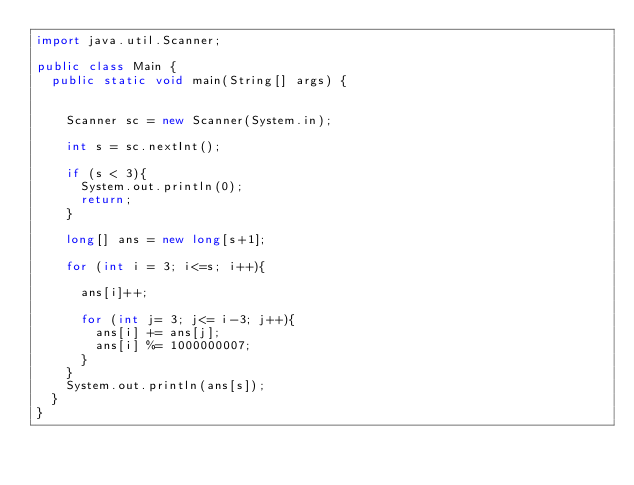<code> <loc_0><loc_0><loc_500><loc_500><_Java_>import java.util.Scanner;

public class Main {
	public static void main(String[] args) {


		Scanner sc = new Scanner(System.in);

		int s = sc.nextInt();

		if (s < 3){
			System.out.println(0);
			return;
		}

		long[] ans = new long[s+1];

		for (int i = 3; i<=s; i++){

			ans[i]++;

			for (int j= 3; j<= i-3; j++){
				ans[i] += ans[j];
				ans[i] %= 1000000007;
			}
		}
		System.out.println(ans[s]);
	}
}</code> 